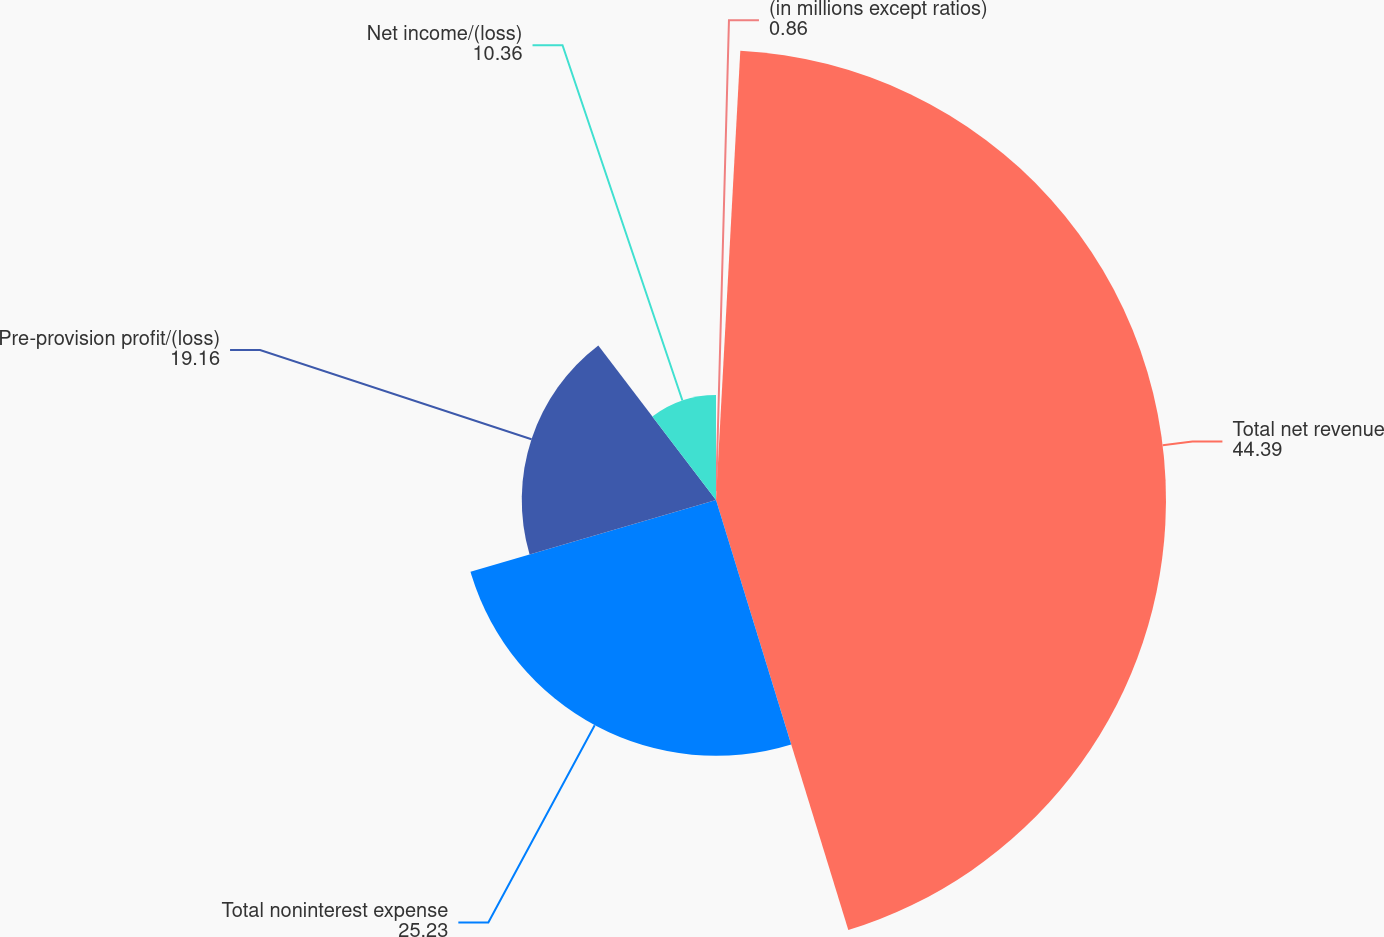<chart> <loc_0><loc_0><loc_500><loc_500><pie_chart><fcel>(in millions except ratios)<fcel>Total net revenue<fcel>Total noninterest expense<fcel>Pre-provision profit/(loss)<fcel>Net income/(loss)<nl><fcel>0.86%<fcel>44.39%<fcel>25.23%<fcel>19.16%<fcel>10.36%<nl></chart> 